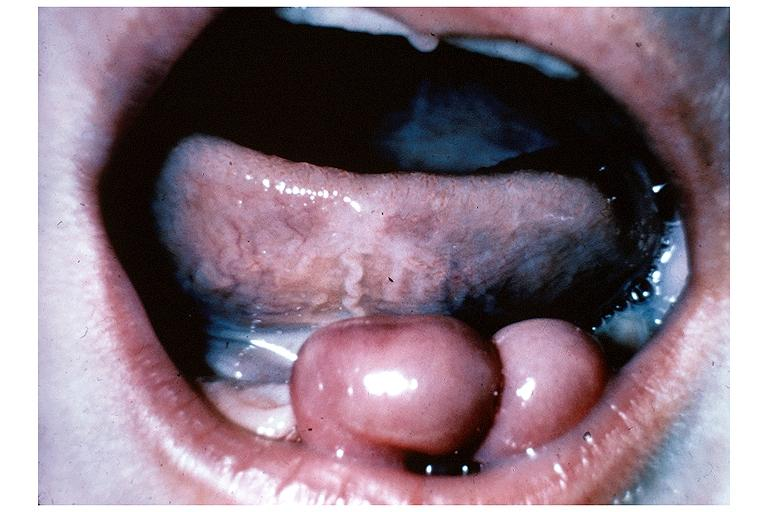s oral present?
Answer the question using a single word or phrase. Yes 